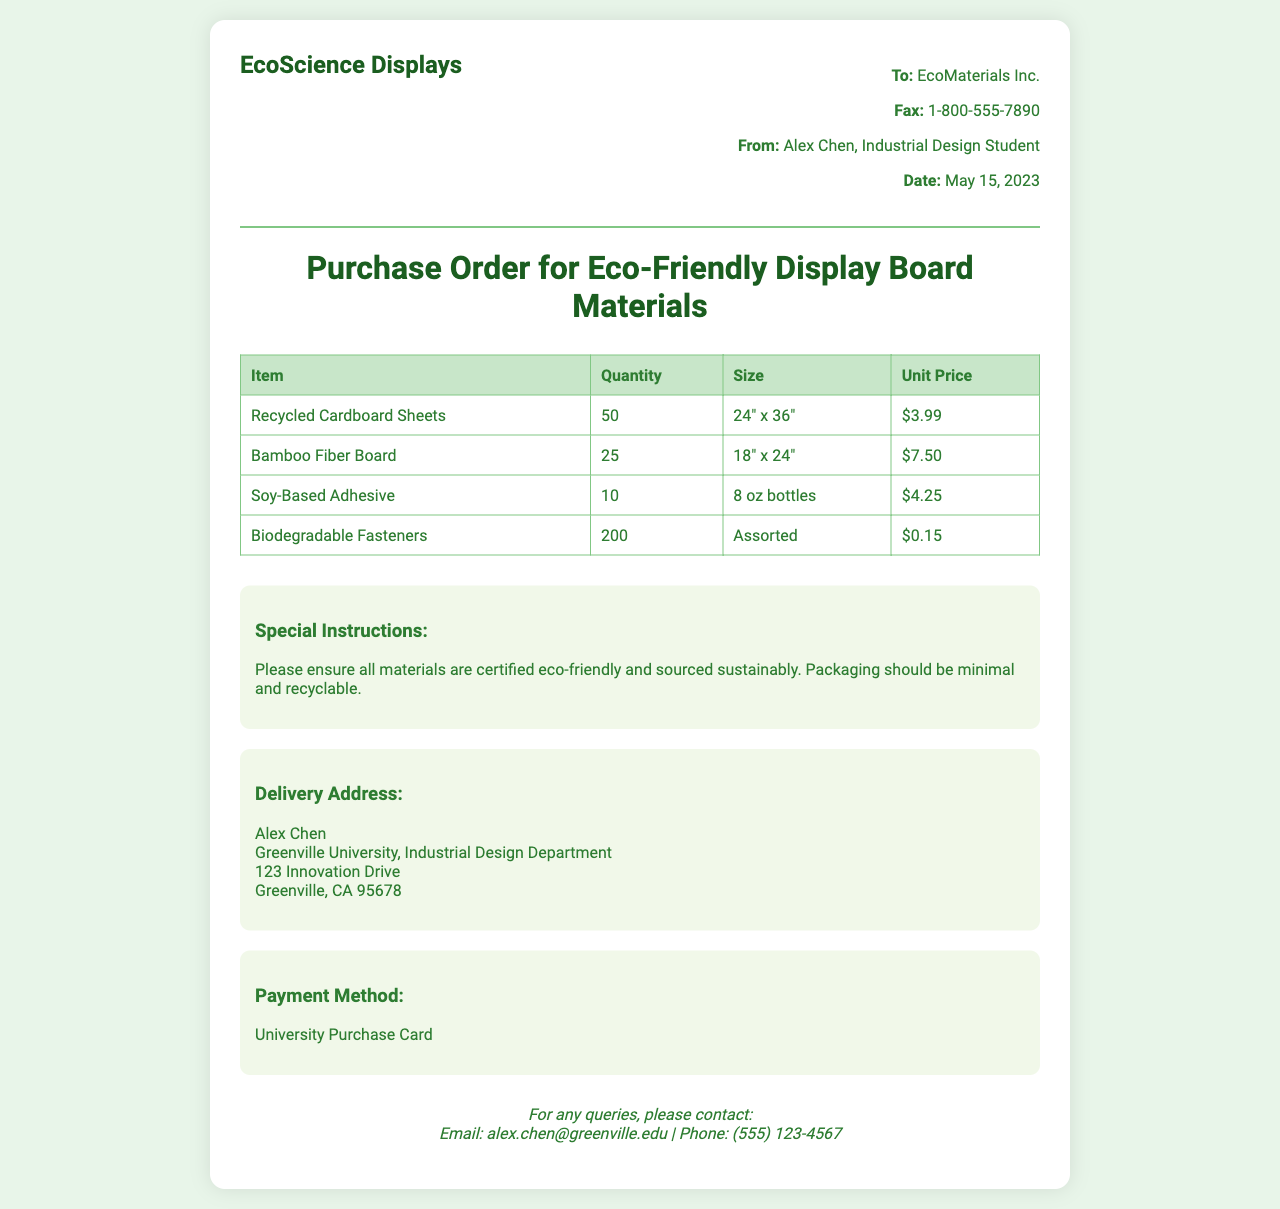What is the name of the sender? The sender's name is listed at the top of the document as Alex Chen.
Answer: Alex Chen When was the purchase order faxed? The date on the fax indicates when the order was sent, which is May 15, 2023.
Answer: May 15, 2023 How many Recycled Cardboard Sheets are requested? The document specifies a quantity of 50 for Recycled Cardboard Sheets.
Answer: 50 What is the unit price of Bamboo Fiber Board? The price listed for Bamboo Fiber Board is provided in the table, which is $7.50.
Answer: $7.50 What is the delivery address? The delivery address is where the materials will be sent, as stated in the document.
Answer: 123 Innovation Drive, Greenville, CA 95678 Which payment method is mentioned? The document specifies that the payment will be made using a University Purchase Card.
Answer: University Purchase Card Why should the materials be chosen carefully? The special instructions note the need for certified eco-friendly materials, indicating environmental considerations.
Answer: Certified eco-friendly What is the quantity of Biodegradable Fasteners requested? The table indicates that 200 Biodegradable Fasteners are to be ordered.
Answer: 200 